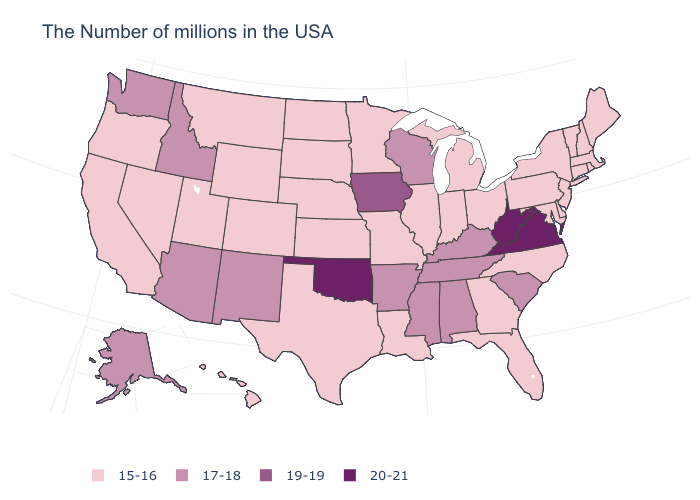Name the states that have a value in the range 17-18?
Answer briefly. South Carolina, Kentucky, Alabama, Tennessee, Wisconsin, Mississippi, Arkansas, New Mexico, Arizona, Idaho, Washington, Alaska. What is the value of Rhode Island?
Answer briefly. 15-16. Does Oklahoma have the lowest value in the South?
Answer briefly. No. What is the value of Ohio?
Answer briefly. 15-16. Does the first symbol in the legend represent the smallest category?
Quick response, please. Yes. Does Kentucky have the same value as Vermont?
Answer briefly. No. How many symbols are there in the legend?
Give a very brief answer. 4. What is the value of Kentucky?
Write a very short answer. 17-18. Which states have the lowest value in the USA?
Concise answer only. Maine, Massachusetts, Rhode Island, New Hampshire, Vermont, Connecticut, New York, New Jersey, Delaware, Maryland, Pennsylvania, North Carolina, Ohio, Florida, Georgia, Michigan, Indiana, Illinois, Louisiana, Missouri, Minnesota, Kansas, Nebraska, Texas, South Dakota, North Dakota, Wyoming, Colorado, Utah, Montana, Nevada, California, Oregon, Hawaii. What is the highest value in the South ?
Give a very brief answer. 20-21. Name the states that have a value in the range 20-21?
Concise answer only. Virginia, West Virginia, Oklahoma. Name the states that have a value in the range 15-16?
Be succinct. Maine, Massachusetts, Rhode Island, New Hampshire, Vermont, Connecticut, New York, New Jersey, Delaware, Maryland, Pennsylvania, North Carolina, Ohio, Florida, Georgia, Michigan, Indiana, Illinois, Louisiana, Missouri, Minnesota, Kansas, Nebraska, Texas, South Dakota, North Dakota, Wyoming, Colorado, Utah, Montana, Nevada, California, Oregon, Hawaii. What is the value of Idaho?
Concise answer only. 17-18. Among the states that border Florida , which have the highest value?
Be succinct. Alabama. Does Connecticut have the same value as California?
Concise answer only. Yes. 